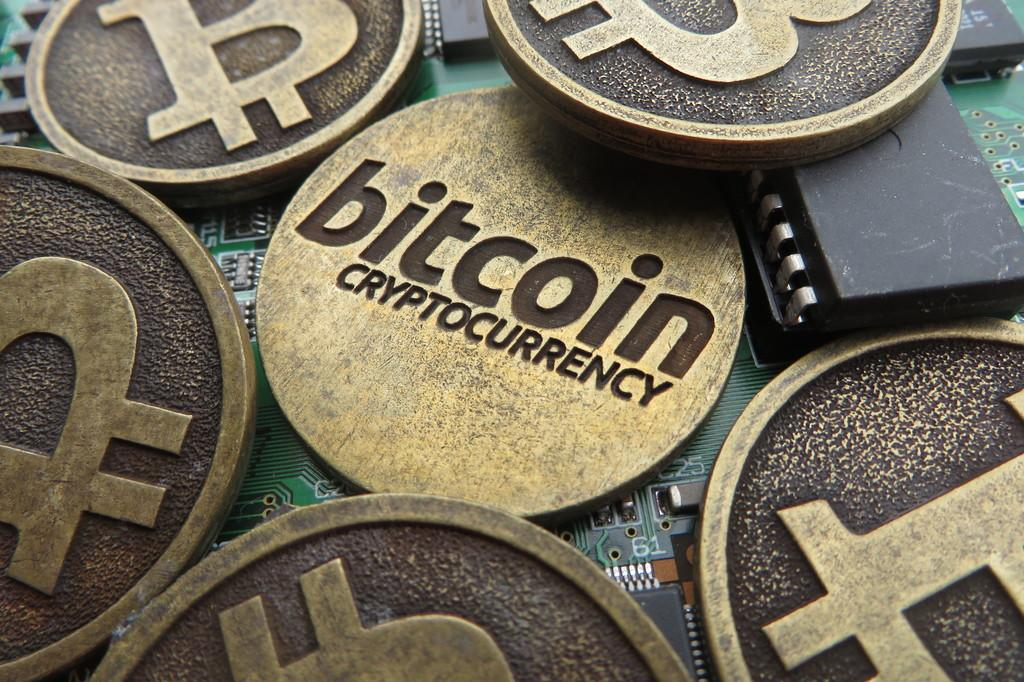<image>
Write a terse but informative summary of the picture. The gold coin in the image reads Bitcoin Crypto Currency 